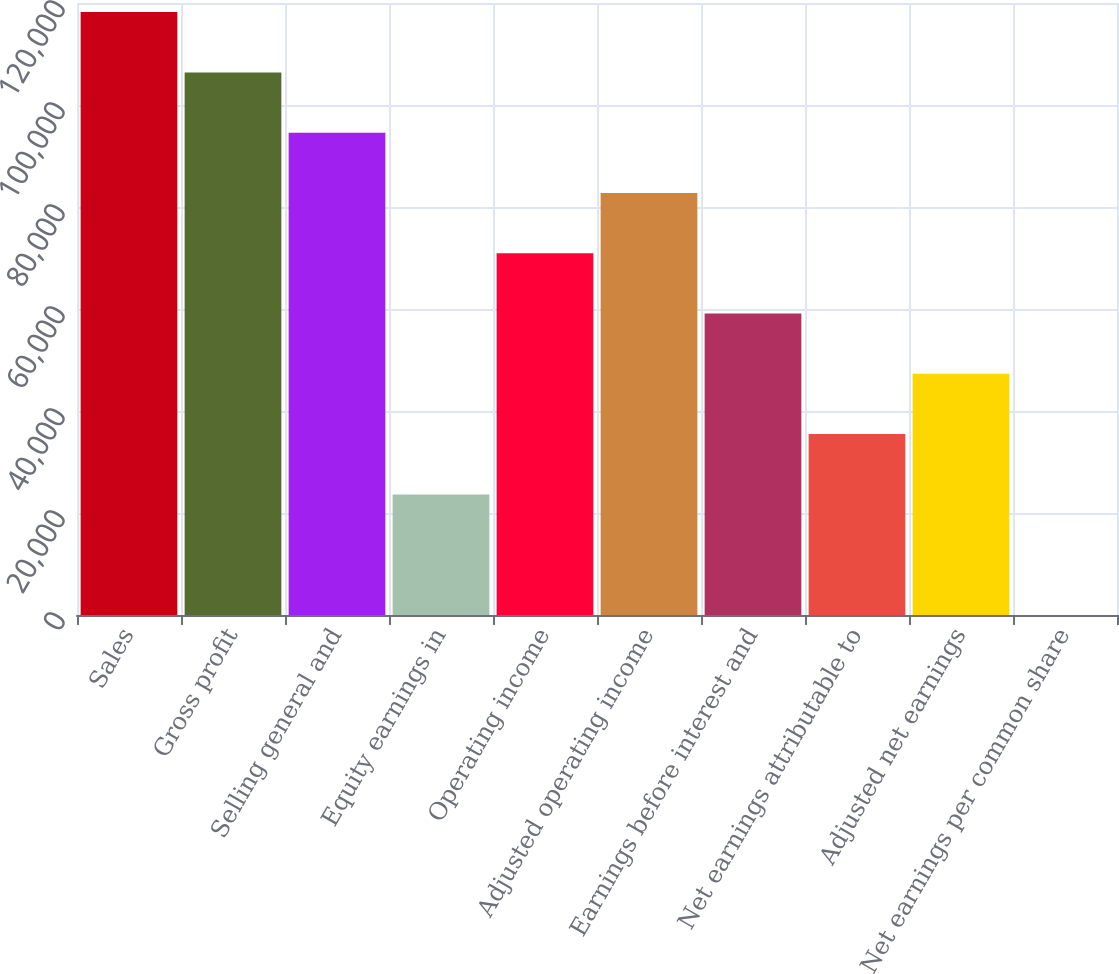<chart> <loc_0><loc_0><loc_500><loc_500><bar_chart><fcel>Sales<fcel>Gross profit<fcel>Selling general and<fcel>Equity earnings in<fcel>Operating income<fcel>Adjusted operating income<fcel>Earnings before interest and<fcel>Net earnings attributable to<fcel>Adjusted net earnings<fcel>Net earnings per common share<nl><fcel>118214<fcel>106393<fcel>94571.9<fcel>23645.8<fcel>70929.9<fcel>82750.9<fcel>59108.9<fcel>35466.8<fcel>47287.9<fcel>3.78<nl></chart> 